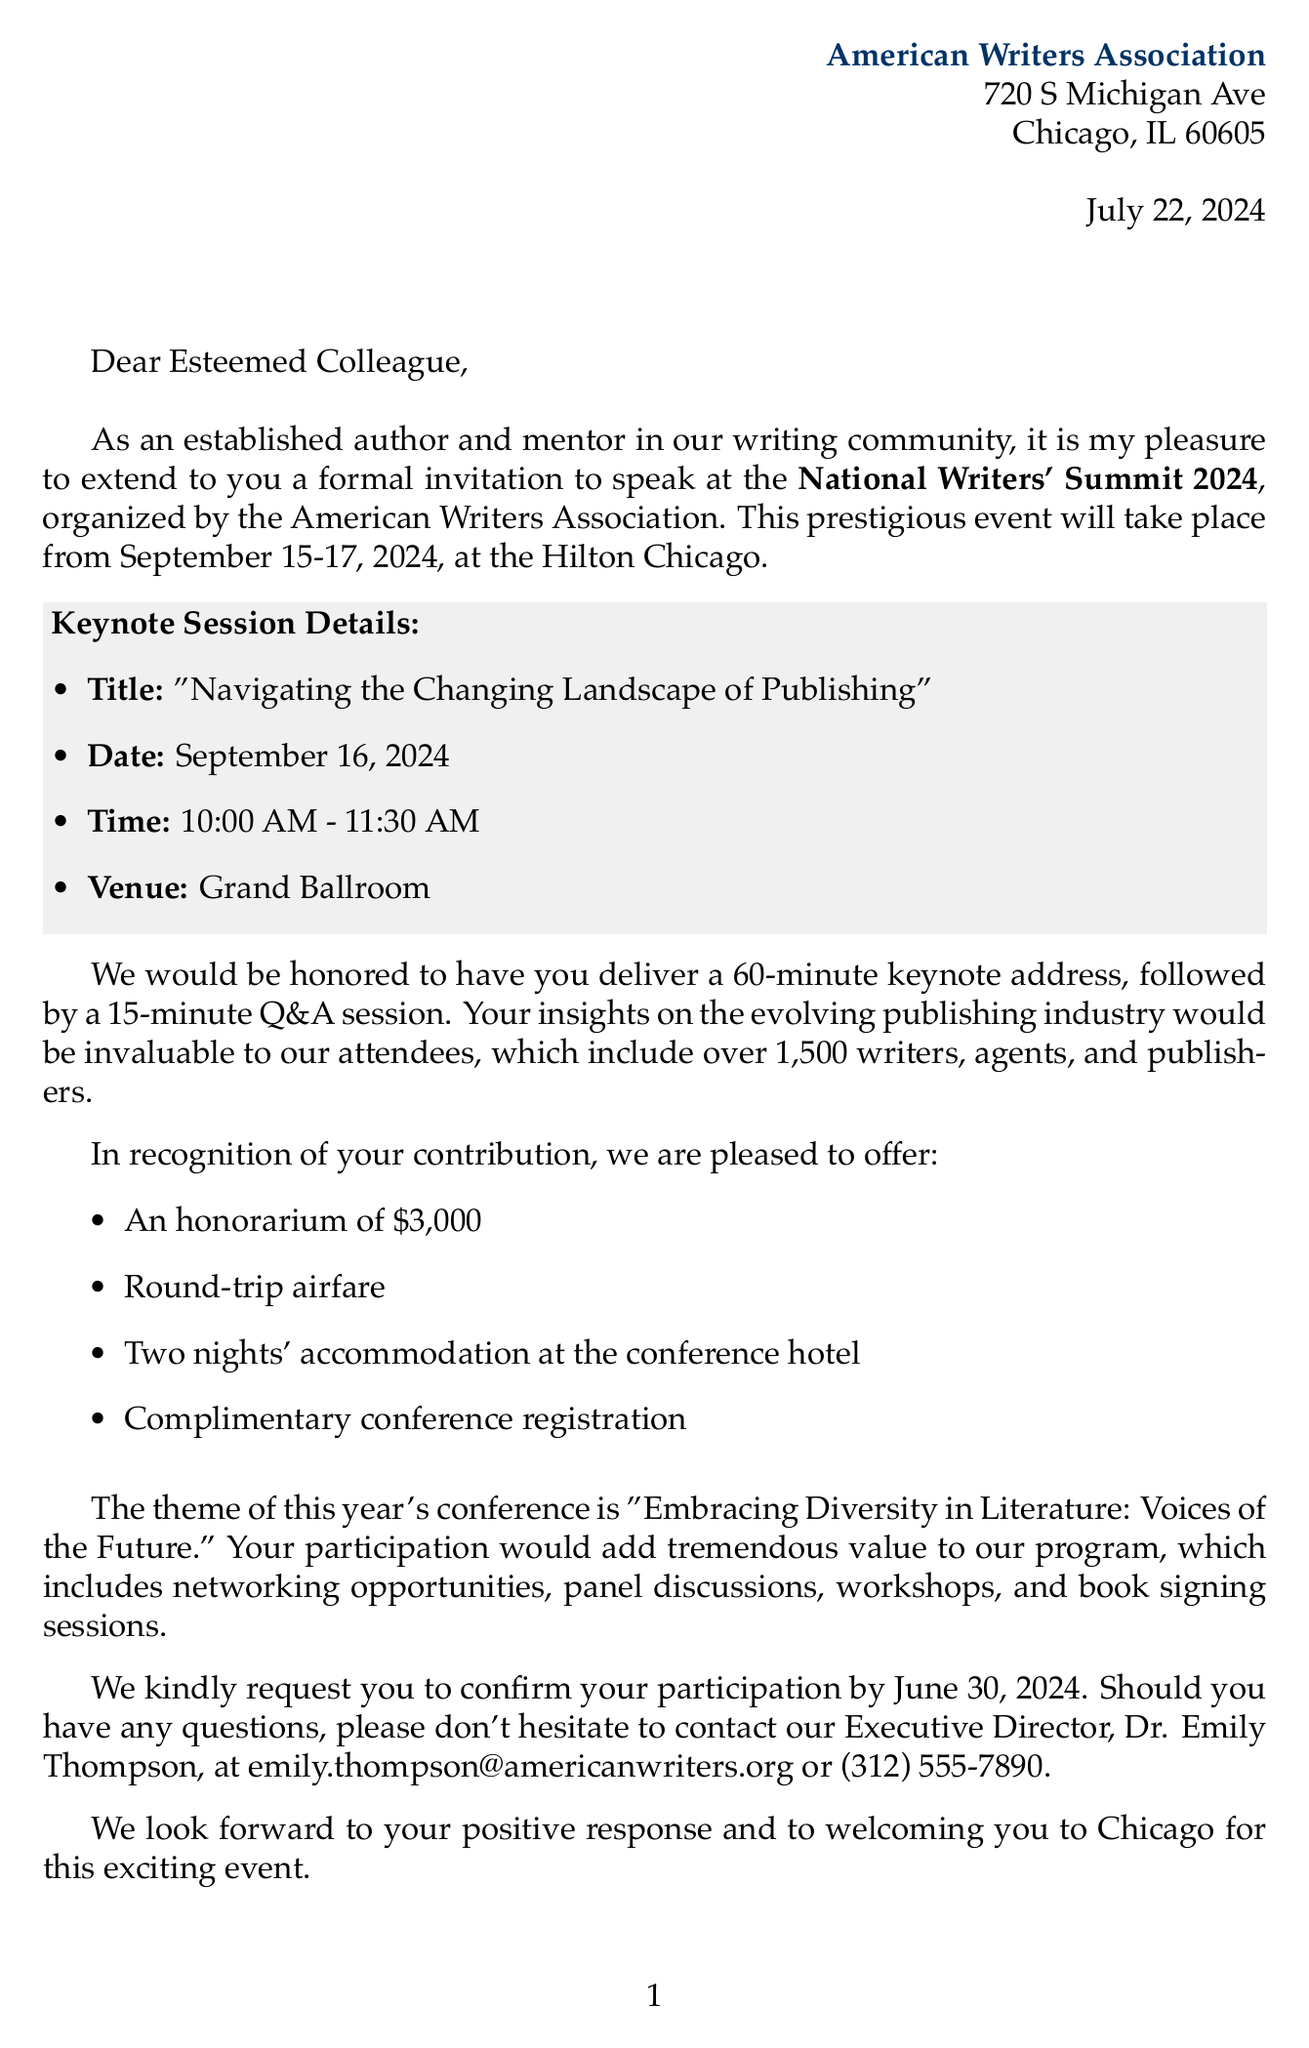What is the name of the conference? The document references the conference as the National Writers' Summit 2024.
Answer: National Writers' Summit 2024 Who is the organizer of the conference? The document specifies that the organizer is the American Writers Association.
Answer: American Writers Association When will the conference take place? The letter indicates the conference dates as September 15-17, 2024.
Answer: September 15-17, 2024 What is the honorarium amount offered to speakers? The document states the honorarium amount as $3,000.
Answer: $3,000 What is the theme of the conference? The document mentions the theme as "Embracing Diversity in Literature: Voices of the Future."
Answer: Embracing Diversity in Literature: Voices of the Future What are two benefits included in the honorarium? The letter lists round-trip airfare and two nights' accommodation as included benefits.
Answer: Round-trip airfare, two nights' accommodation How long is the keynote address expected to be? The document specifies that the keynote address is a 60-minute talk.
Answer: 60 minutes What is the last date to confirm participation? The letter states that the confirmation deadline is June 30, 2024.
Answer: June 30, 2024 How many writers, agents, and publishers are expected to attend? The document notes that over 1,500 attendees are expected.
Answer: Over 1,500 